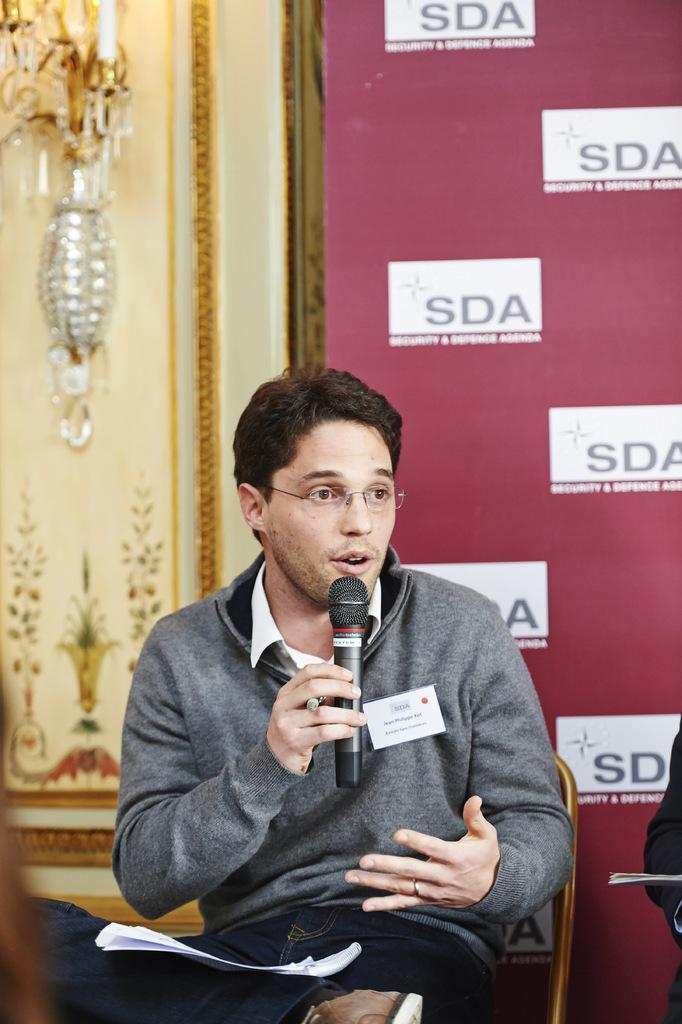Who is present in the image? There is a man in the image. What is the man doing in the image? The man is sitting on a chair and holding a microphone. Can you describe the man's appearance? The man is wearing spectacles. What can be seen in the background of the image? There is a banner in the background of the image. What type of gate is visible in the image? There is no gate present in the image. What is the reason for the man holding the microphone in the image? The image does not provide any information about the reason for the man holding the microphone. 